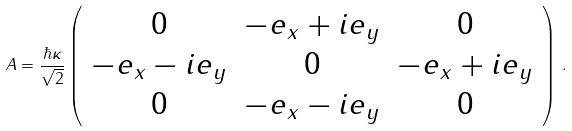<formula> <loc_0><loc_0><loc_500><loc_500>A = \frac { \hbar { \kappa } } { \sqrt { 2 } } \left ( \begin{array} { c c c } 0 & - e _ { x } + i e _ { y } & 0 \\ - e _ { x } - i e _ { y } & 0 & - e _ { x } + i e _ { y } \\ 0 & - e _ { x } - i e _ { y } & 0 \end{array} \right ) \, .</formula> 